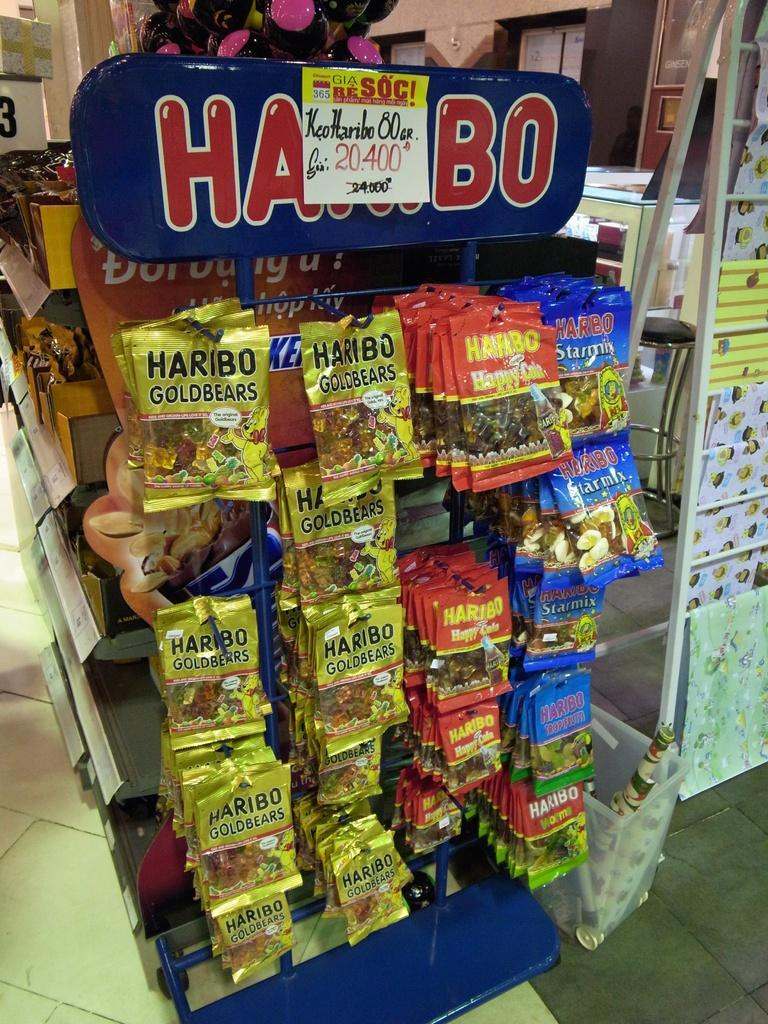<image>
Give a short and clear explanation of the subsequent image. a display of HARIBO gummies like Gold Bears and Starmix 